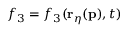<formula> <loc_0><loc_0><loc_500><loc_500>f _ { 3 } = f _ { 3 } ( r _ { \eta } ( p ) , t )</formula> 